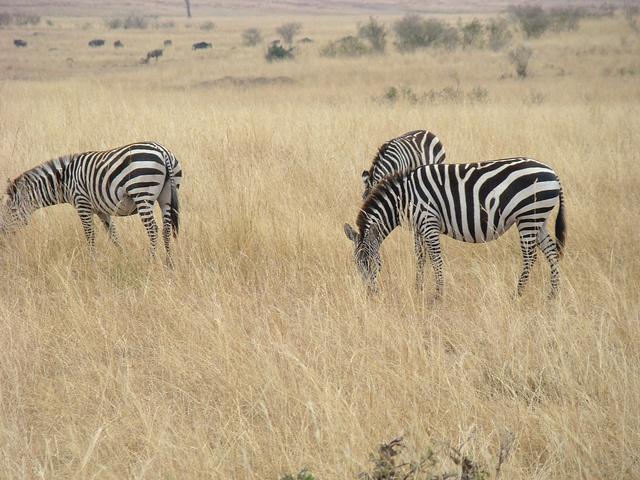Describe the objects in this image and their specific colors. I can see zebra in darkgray, black, gray, and tan tones, zebra in darkgray, black, gray, and tan tones, and zebra in darkgray, gray, black, and lightgray tones in this image. 